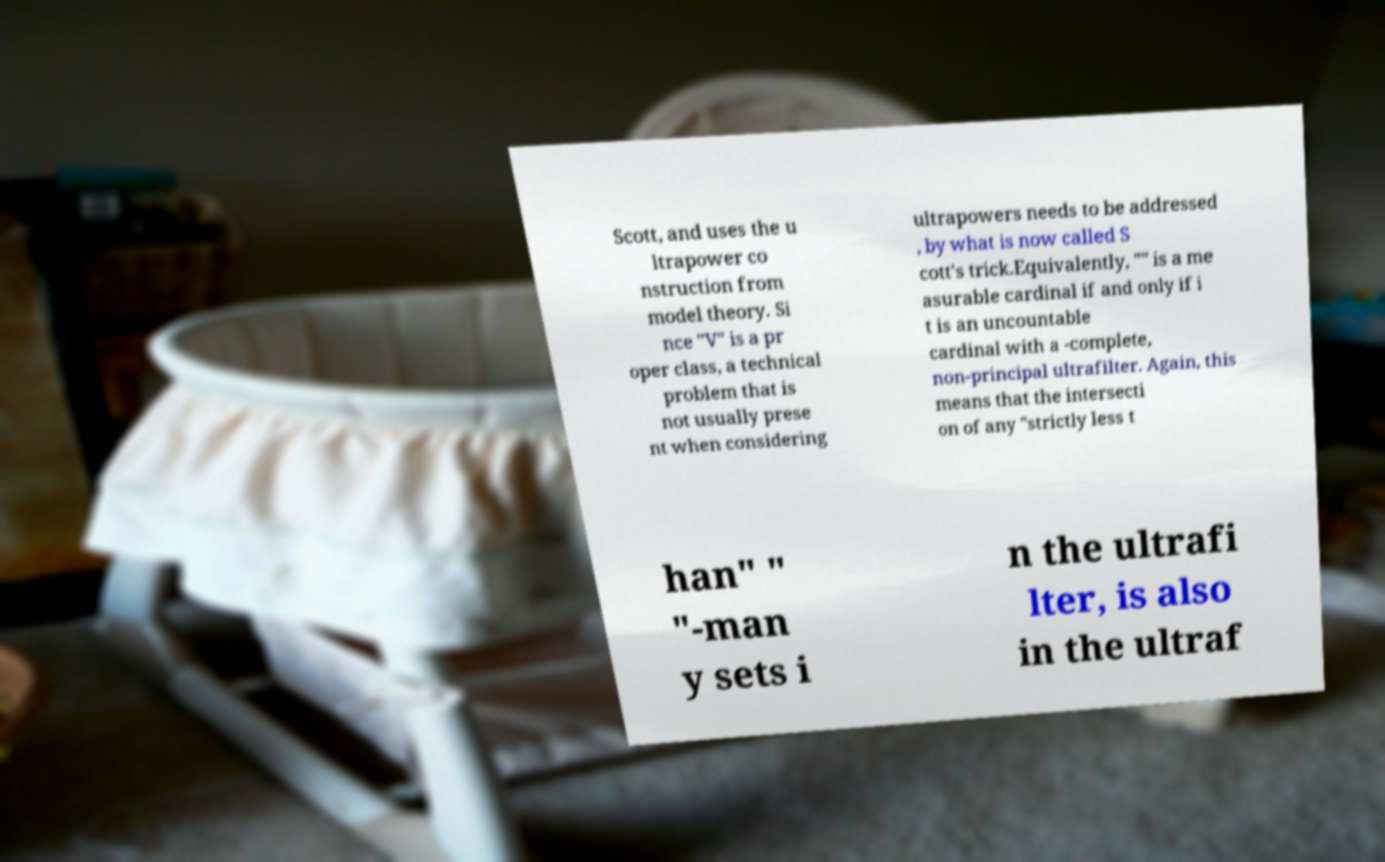Please identify and transcribe the text found in this image. Scott, and uses the u ltrapower co nstruction from model theory. Si nce "V" is a pr oper class, a technical problem that is not usually prese nt when considering ultrapowers needs to be addressed , by what is now called S cott's trick.Equivalently, "" is a me asurable cardinal if and only if i t is an uncountable cardinal with a -complete, non-principal ultrafilter. Again, this means that the intersecti on of any "strictly less t han" " "-man y sets i n the ultrafi lter, is also in the ultraf 